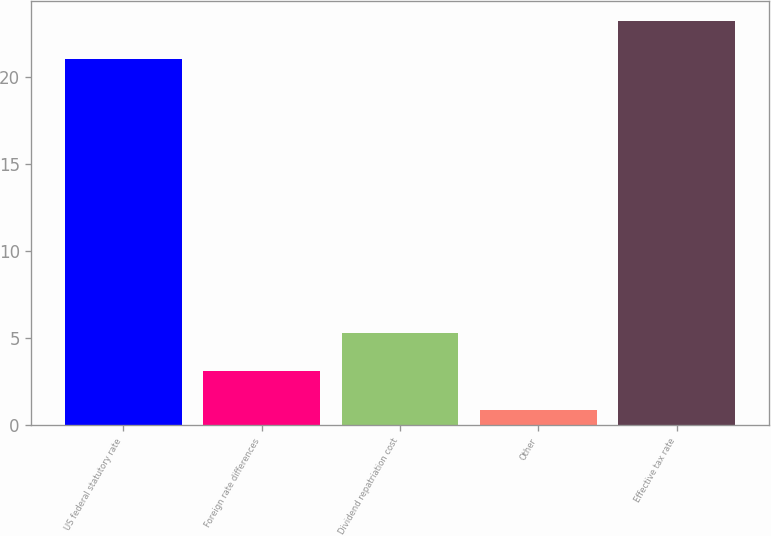<chart> <loc_0><loc_0><loc_500><loc_500><bar_chart><fcel>US federal statutory rate<fcel>Foreign rate differences<fcel>Dividend repatriation cost<fcel>Other<fcel>Effective tax rate<nl><fcel>21<fcel>3.1<fcel>5.3<fcel>0.9<fcel>23.2<nl></chart> 